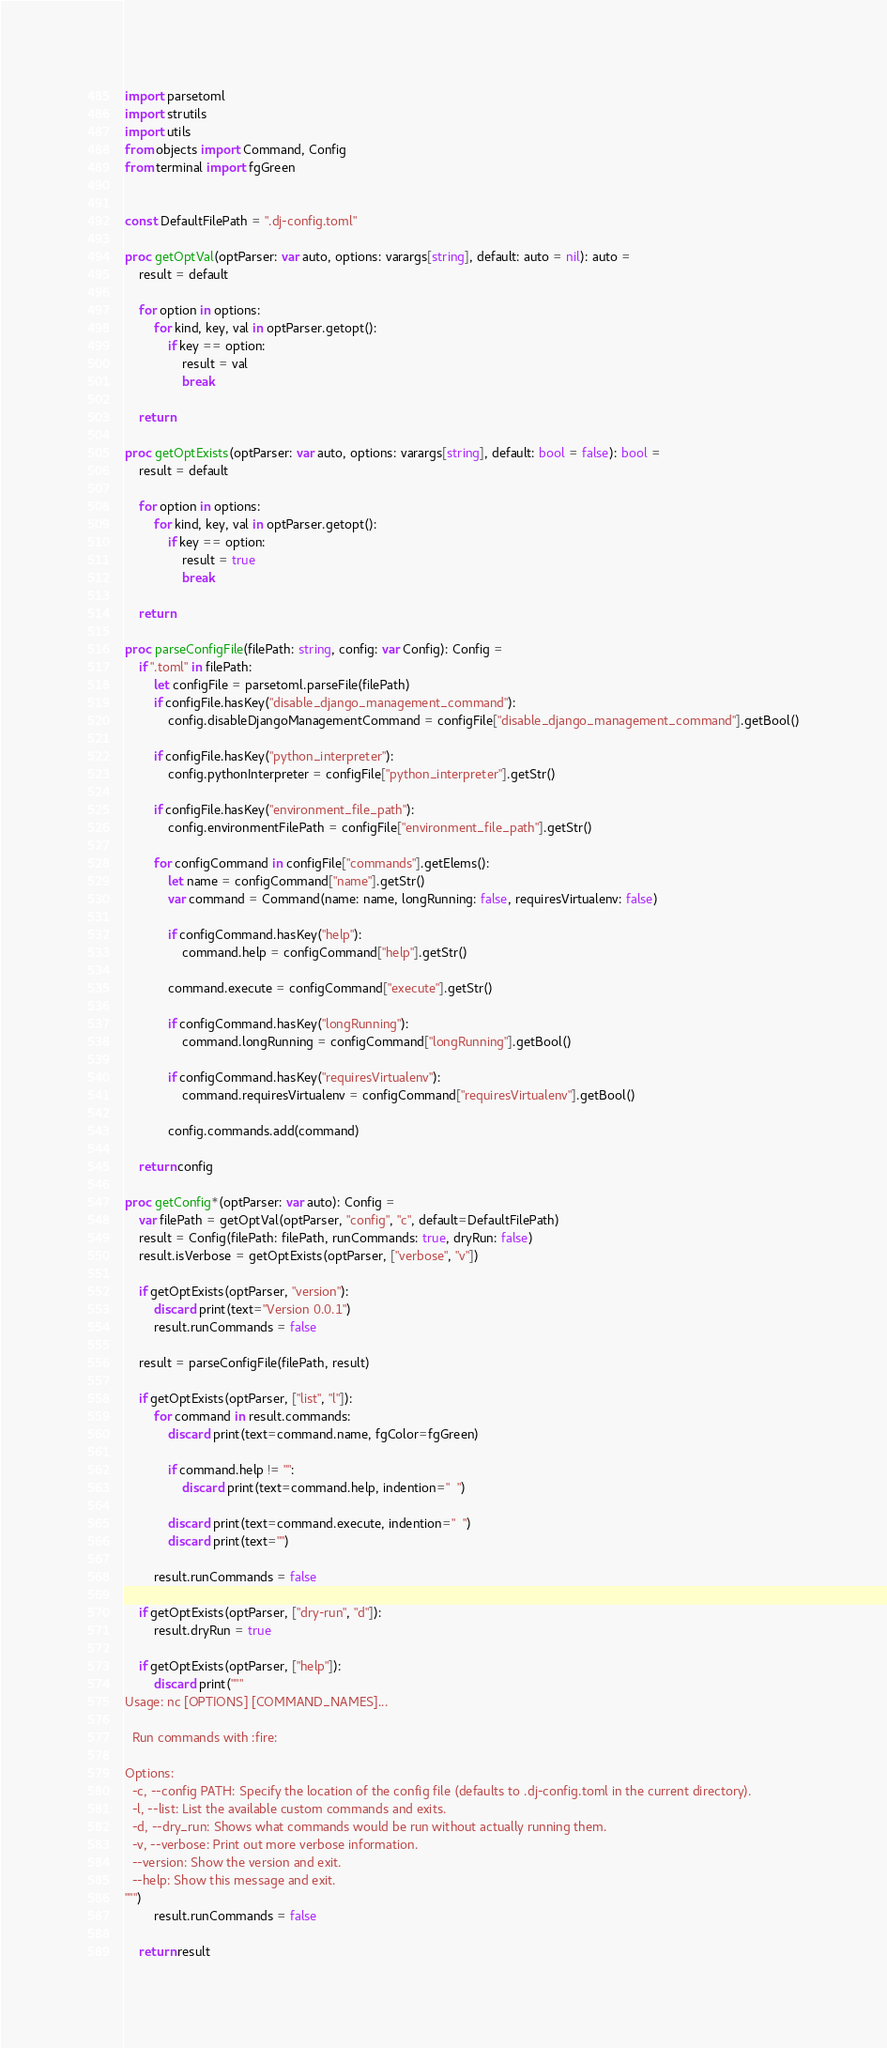Convert code to text. <code><loc_0><loc_0><loc_500><loc_500><_Nim_>import parsetoml
import strutils
import utils
from objects import Command, Config
from terminal import fgGreen


const DefaultFilePath = ".dj-config.toml"

proc getOptVal(optParser: var auto, options: varargs[string], default: auto = nil): auto =
    result = default

    for option in options:
        for kind, key, val in optParser.getopt():
            if key == option:
                result = val
                break

    return

proc getOptExists(optParser: var auto, options: varargs[string], default: bool = false): bool =
    result = default

    for option in options:
        for kind, key, val in optParser.getopt():
            if key == option:
                result = true
                break

    return

proc parseConfigFile(filePath: string, config: var Config): Config =
    if ".toml" in filePath:
        let configFile = parsetoml.parseFile(filePath)
        if configFile.hasKey("disable_django_management_command"):
            config.disableDjangoManagementCommand = configFile["disable_django_management_command"].getBool()
        
        if configFile.hasKey("python_interpreter"):
            config.pythonInterpreter = configFile["python_interpreter"].getStr()

        if configFile.hasKey("environment_file_path"):
            config.environmentFilePath = configFile["environment_file_path"].getStr()

        for configCommand in configFile["commands"].getElems():
            let name = configCommand["name"].getStr()
            var command = Command(name: name, longRunning: false, requiresVirtualenv: false)        

            if configCommand.hasKey("help"):
                command.help = configCommand["help"].getStr()

            command.execute = configCommand["execute"].getStr()

            if configCommand.hasKey("longRunning"):
                command.longRunning = configCommand["longRunning"].getBool()
            
            if configCommand.hasKey("requiresVirtualenv"):
                command.requiresVirtualenv = configCommand["requiresVirtualenv"].getBool()
            
            config.commands.add(command)
    
    return config

proc getConfig*(optParser: var auto): Config =
    var filePath = getOptVal(optParser, "config", "c", default=DefaultFilePath)
    result = Config(filePath: filePath, runCommands: true, dryRun: false)
    result.isVerbose = getOptExists(optParser, ["verbose", "v"])

    if getOptExists(optParser, "version"):
        discard print(text="Version 0.0.1")
        result.runCommands = false

    result = parseConfigFile(filePath, result)

    if getOptExists(optParser, ["list", "l"]):
        for command in result.commands:
            discard print(text=command.name, fgColor=fgGreen)

            if command.help != "":
                discard print(text=command.help, indention="  ")

            discard print(text=command.execute, indention="  ")
            discard print(text="")

        result.runCommands = false
    
    if getOptExists(optParser, ["dry-run", "d"]):
        result.dryRun = true
    
    if getOptExists(optParser, ["help"]):
        discard print("""
Usage: nc [OPTIONS] [COMMAND_NAMES]...

  Run commands with :fire:

Options:
  -c, --config PATH: Specify the location of the config file (defaults to .dj-config.toml in the current directory).
  -l, --list: List the available custom commands and exits.
  -d, --dry_run: Shows what commands would be run without actually running them.
  -v, --verbose: Print out more verbose information.
  --version: Show the version and exit.
  --help: Show this message and exit.
""")
        result.runCommands = false

    return result
</code> 